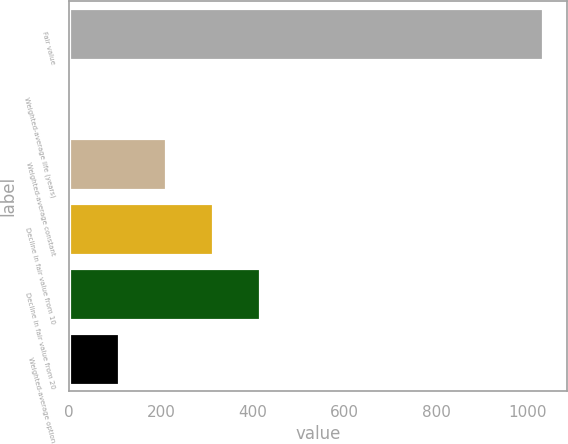<chart> <loc_0><loc_0><loc_500><loc_500><bar_chart><fcel>Fair value<fcel>Weighted-average life (years)<fcel>Weighted-average constant<fcel>Decline in fair value from 10<fcel>Decline in fair value from 20<fcel>Weighted-average option<nl><fcel>1033<fcel>5.8<fcel>211.24<fcel>313.96<fcel>416.68<fcel>108.52<nl></chart> 